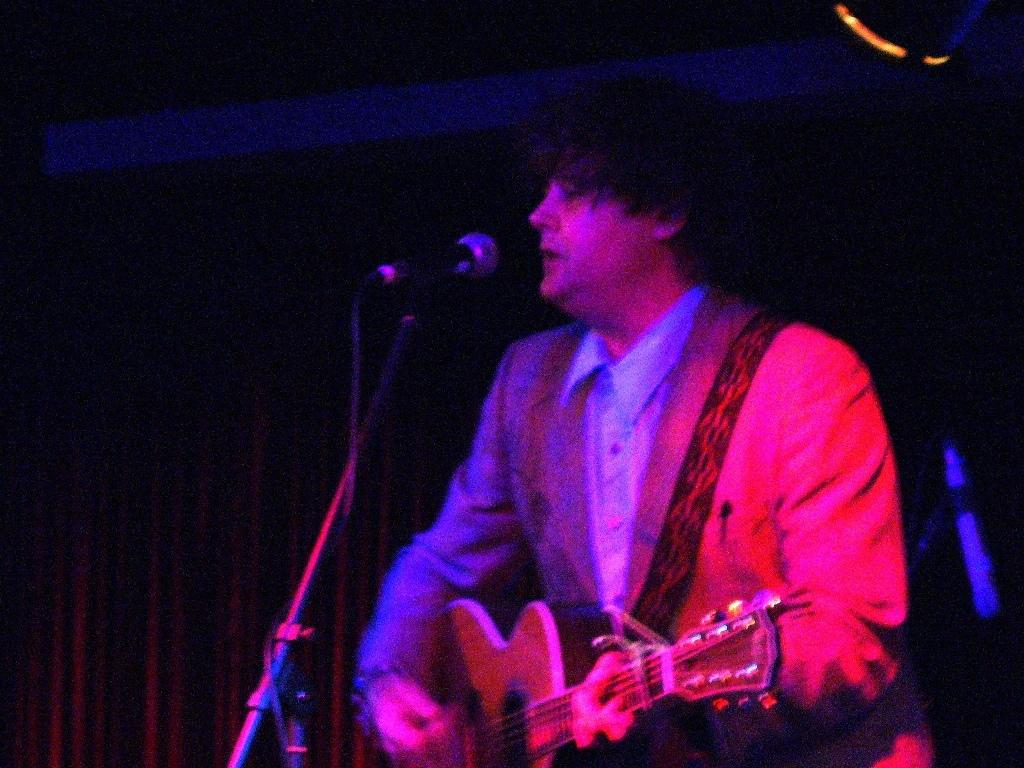What is the person in the image doing? The person is playing guitar and singing in the image. What is the person using to amplify their voice? There is a microphone with a stand in front of the person. What type of background can be seen in the image? There are curtains visible in the image. What can be seen illuminating the scene? There are lights visible in the image. What type of popcorn is being distributed to the audience in the image? There is no popcorn or audience present in the image; it features a person playing guitar and singing with a microphone and lights. 